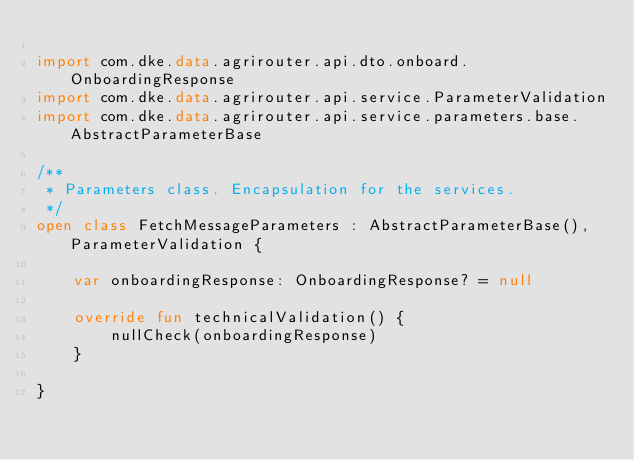Convert code to text. <code><loc_0><loc_0><loc_500><loc_500><_Kotlin_>
import com.dke.data.agrirouter.api.dto.onboard.OnboardingResponse
import com.dke.data.agrirouter.api.service.ParameterValidation
import com.dke.data.agrirouter.api.service.parameters.base.AbstractParameterBase

/**
 * Parameters class. Encapsulation for the services.
 */
open class FetchMessageParameters : AbstractParameterBase(), ParameterValidation {

    var onboardingResponse: OnboardingResponse? = null

    override fun technicalValidation() {
        nullCheck(onboardingResponse)
    }

}</code> 